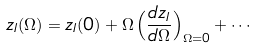<formula> <loc_0><loc_0><loc_500><loc_500>z _ { I } ( \Omega ) = z _ { I } ( 0 ) + \Omega \left ( \frac { d z _ { I } } { d \Omega } \right ) _ { \Omega = 0 } + \cdots</formula> 